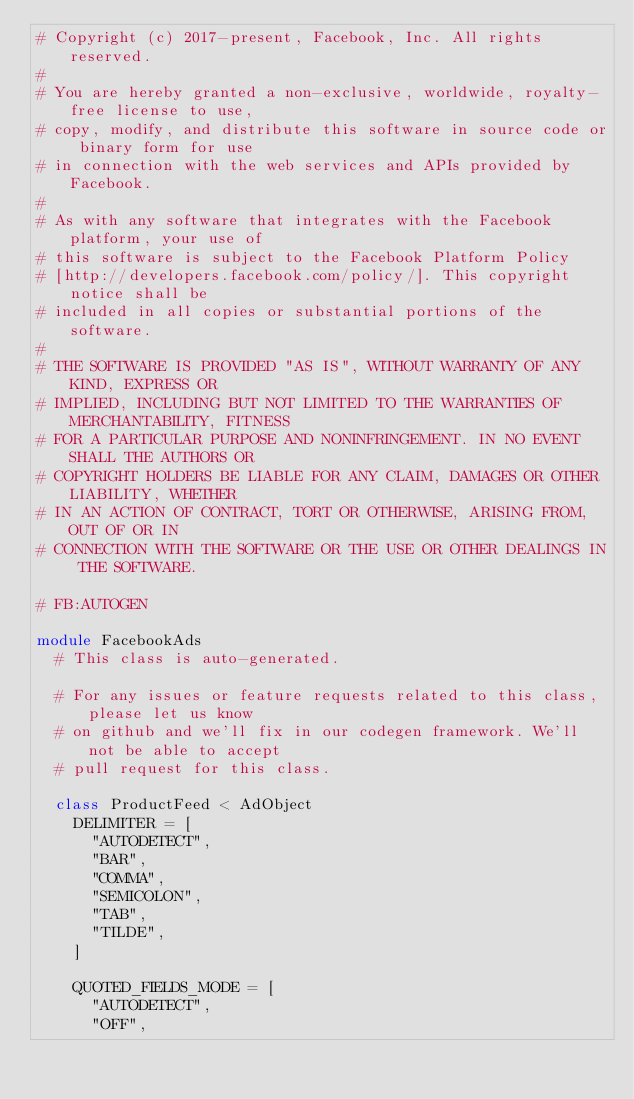Convert code to text. <code><loc_0><loc_0><loc_500><loc_500><_Ruby_># Copyright (c) 2017-present, Facebook, Inc. All rights reserved.
#
# You are hereby granted a non-exclusive, worldwide, royalty-free license to use,
# copy, modify, and distribute this software in source code or binary form for use
# in connection with the web services and APIs provided by Facebook.
#
# As with any software that integrates with the Facebook platform, your use of
# this software is subject to the Facebook Platform Policy
# [http://developers.facebook.com/policy/]. This copyright notice shall be
# included in all copies or substantial portions of the software.
#
# THE SOFTWARE IS PROVIDED "AS IS", WITHOUT WARRANTY OF ANY KIND, EXPRESS OR
# IMPLIED, INCLUDING BUT NOT LIMITED TO THE WARRANTIES OF MERCHANTABILITY, FITNESS
# FOR A PARTICULAR PURPOSE AND NONINFRINGEMENT. IN NO EVENT SHALL THE AUTHORS OR
# COPYRIGHT HOLDERS BE LIABLE FOR ANY CLAIM, DAMAGES OR OTHER LIABILITY, WHETHER
# IN AN ACTION OF CONTRACT, TORT OR OTHERWISE, ARISING FROM, OUT OF OR IN
# CONNECTION WITH THE SOFTWARE OR THE USE OR OTHER DEALINGS IN THE SOFTWARE.

# FB:AUTOGEN

module FacebookAds
  # This class is auto-generated.

  # For any issues or feature requests related to this class, please let us know
  # on github and we'll fix in our codegen framework. We'll not be able to accept
  # pull request for this class.

  class ProductFeed < AdObject
    DELIMITER = [
      "AUTODETECT",
      "BAR",
      "COMMA",
      "SEMICOLON",
      "TAB",
      "TILDE",
    ]

    QUOTED_FIELDS_MODE = [
      "AUTODETECT",
      "OFF",</code> 